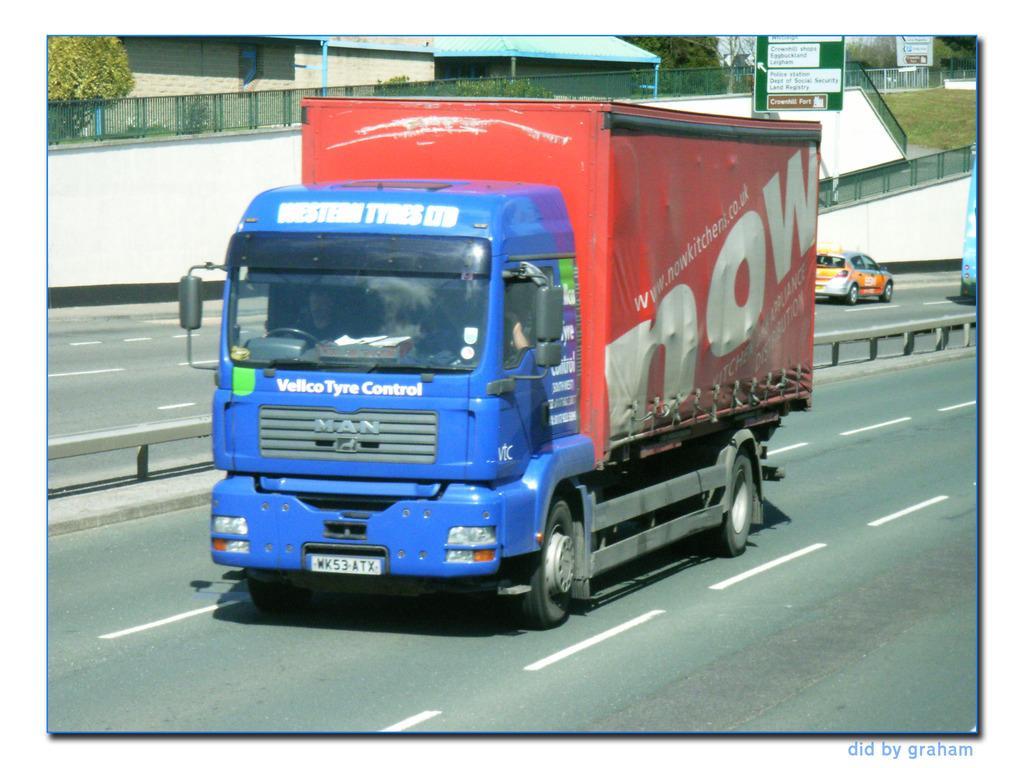How would you summarize this image in a sentence or two? In this image I can see few vehicles on the road. In the background I can see the board, railing, houses and many trees. 